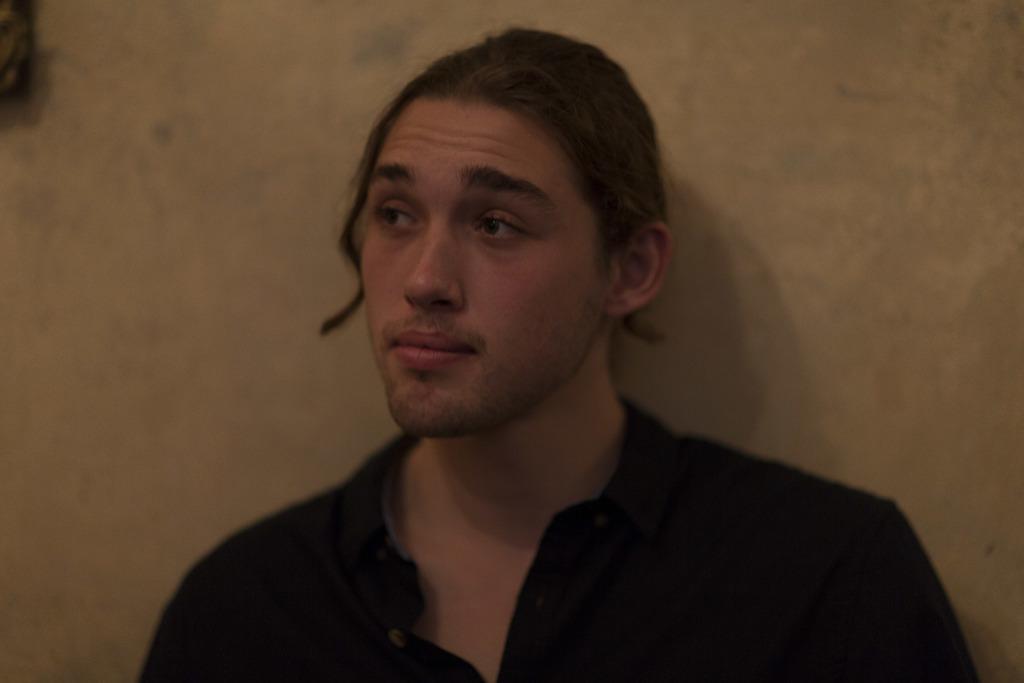Describe this image in one or two sentences. In this picture we can see a person wearing a shirt. The hair colour of the person is golden brown in colour. On the background we can see a wall. 